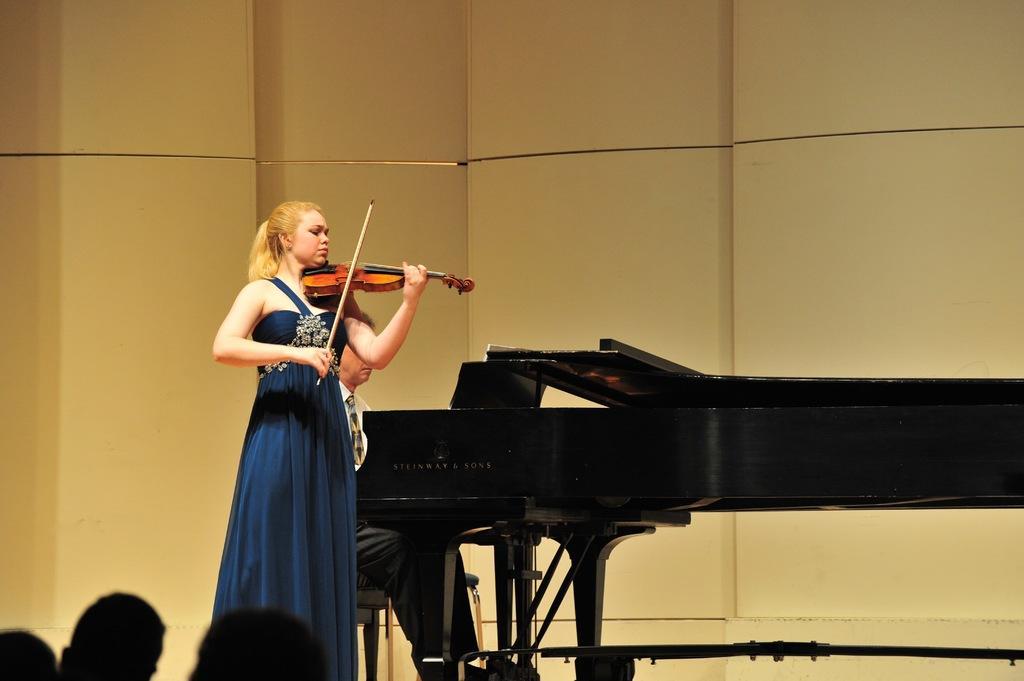How would you summarize this image in a sentence or two? This woman is standing wore blue dress holding a stick and violin. This person is sitting on a chair, in-front of this person there is piano keyboard. 